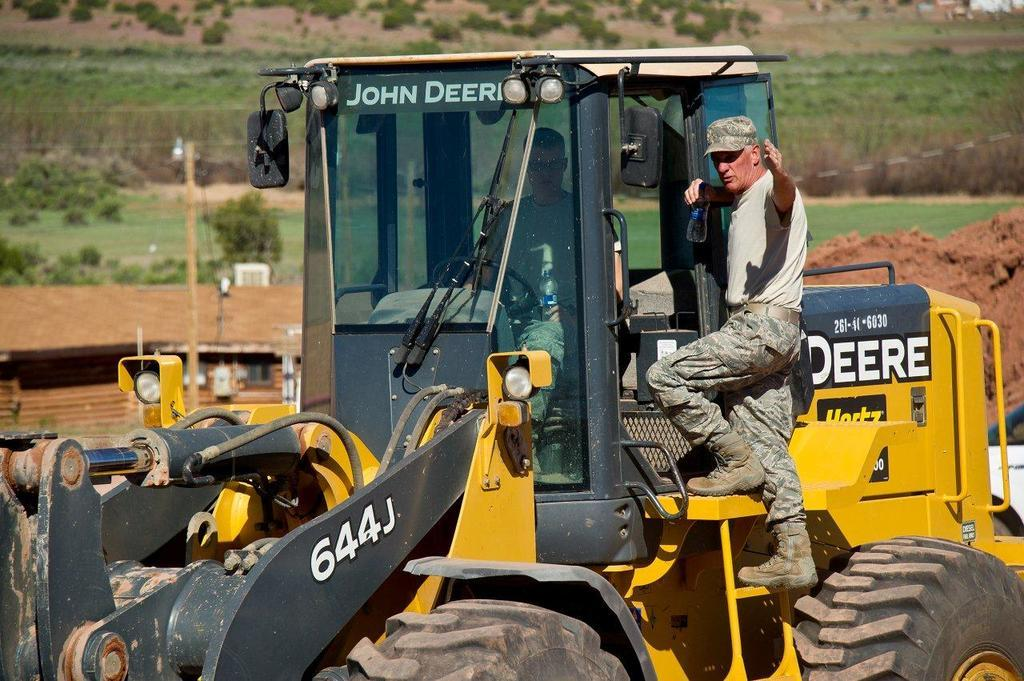What is the main subject of the image? There is a vehicle in the image. Can you describe the person inside the vehicle? There is a person inside the vehicle. What is the man holding in the image? The man is holding a bottle in the image. How is the man positioned in relation to the vehicle? The man is standing on the vehicle. What can be seen in the background of the image? There are trees in the background of the image. How many dogs are present in the image? There are no dogs present in the image. What type of badge is the person wearing inside the vehicle? There is no badge visible on the person inside the vehicle. 